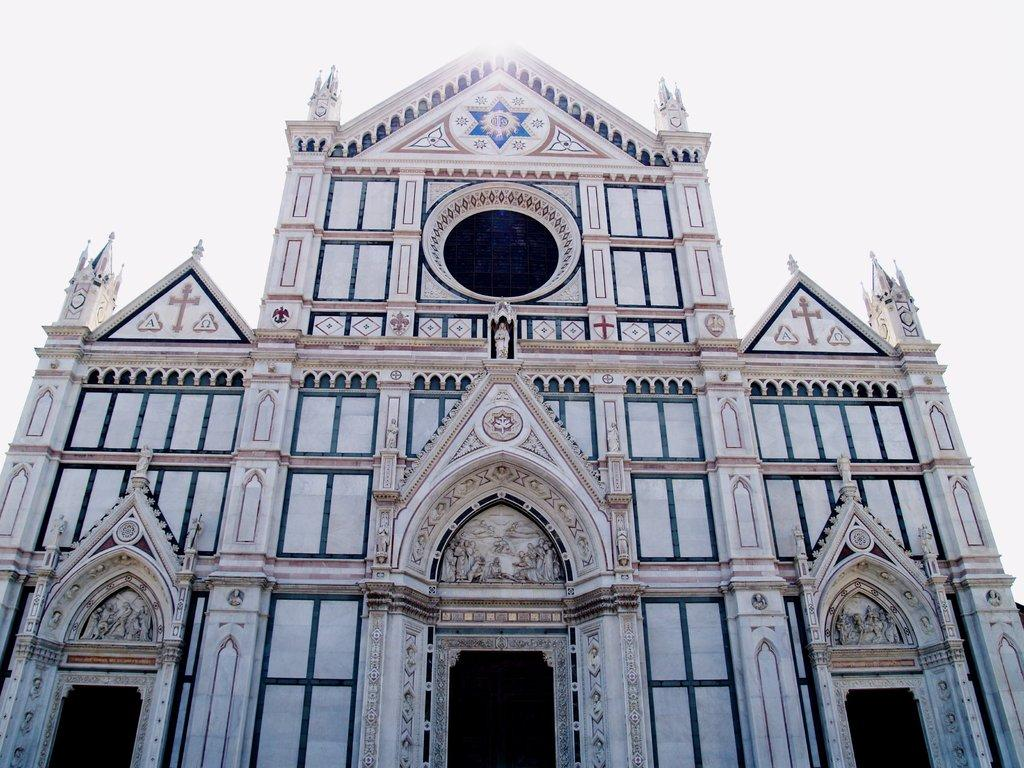What type of building is in the image? There is a church building in the image. What type of spade is being used to support the alarm in the image? There is no spade or alarm present in the image; it only features a church building. 